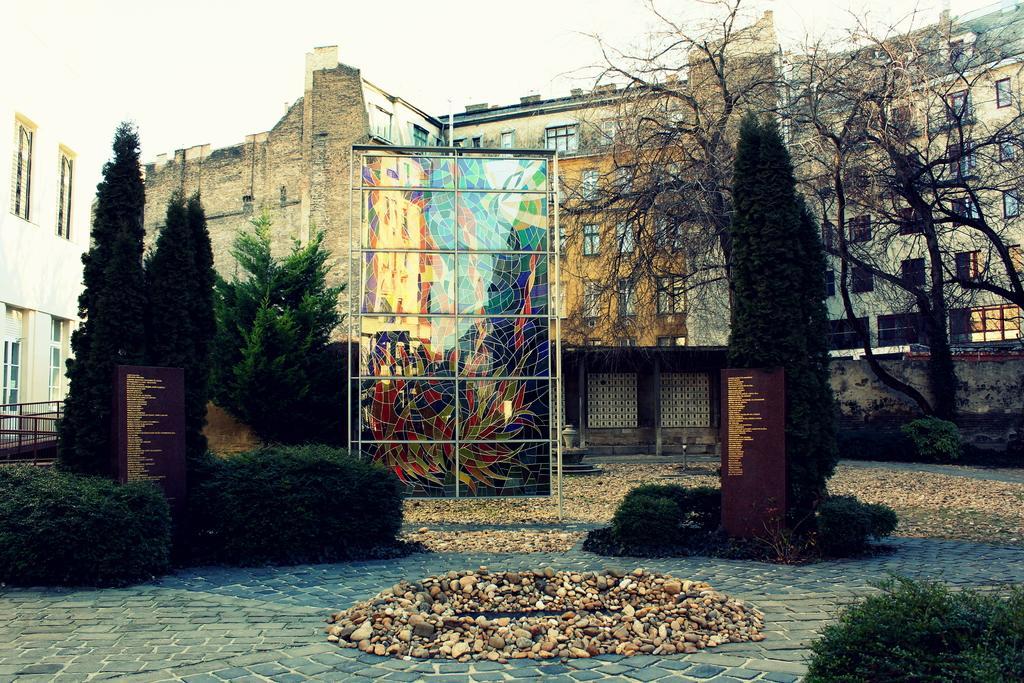Please provide a concise description of this image. In this image I can see trees in green color. In front I can see a brown color board and a multi color glass, background I can see few buildings in cream color and the sky is in white color. 